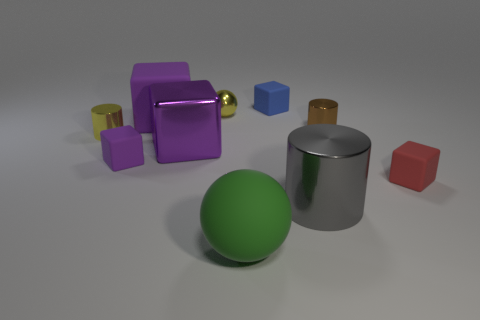Subtract all large purple matte blocks. How many blocks are left? 4 Subtract 3 cylinders. How many cylinders are left? 0 Subtract all purple cubes. How many cubes are left? 2 Subtract all spheres. How many objects are left? 8 Subtract all cyan blocks. How many yellow cylinders are left? 1 Add 4 small balls. How many small balls exist? 5 Subtract 1 brown cylinders. How many objects are left? 9 Subtract all yellow cylinders. Subtract all red cubes. How many cylinders are left? 2 Subtract all big blue balls. Subtract all tiny cylinders. How many objects are left? 8 Add 2 matte blocks. How many matte blocks are left? 6 